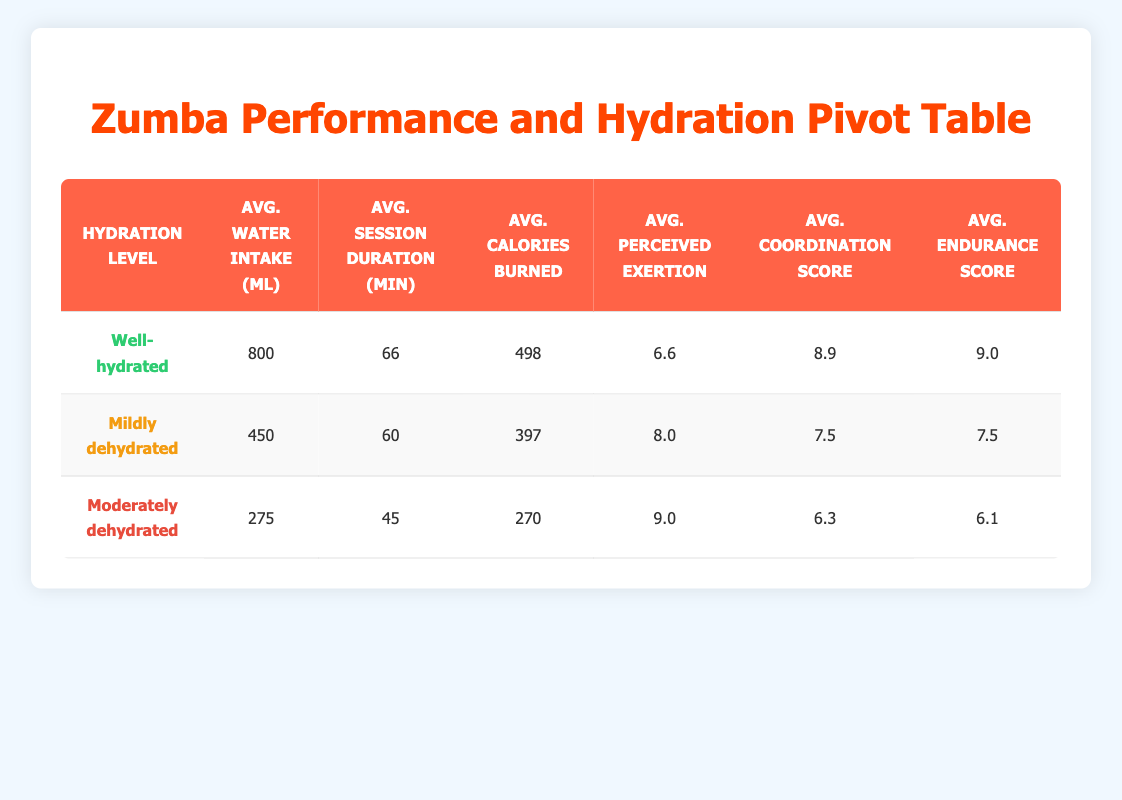What is the average water intake for participants classified as "Well-hydrated"? The table presents an average water intake of 800 ml for participants under the "Well-hydrated" category. This value is directly pulled from the corresponding row in the table.
Answer: 800 ml How many minutes do "Moderately dehydrated" participants spend on average in Zumba sessions? The table shows that "Moderately dehydrated" participants have an average session duration of 45 minutes, which is stated in the respective row.
Answer: 45 min Is the average coordination score higher for "Well-hydrated" participants than for "Mildly dehydrated" participants? Looking at the table, the average coordination score for "Well-hydrated" participants is 8.9, while for "Mildly dehydrated" participants, it is 7.5. Thus, 8.9 is greater than 7.5, making the statement true.
Answer: Yes What is the total average calorie burn for all hydration levels combined? To find this, sum the average calories burned across all hydration levels: 498 (Well-hydrated) + 397 (Mildly dehydrated) + 270 (Moderately dehydrated) = 1165. Then divide by 3 to get an average of 1165/3, which equals approximately 388.33.
Answer: 388.33 How much more does the average calories burned differ between "Well-hydrated" and "Moderately dehydrated" participants? The average calories burned for "Well-hydrated" is 498, and for "Moderately dehydrated," it is 270. The difference is 498 - 270 = 228 calories.
Answer: 228 calories Are participants classified as "Mildly dehydrated" likely to have a higher perceived exertion than those who are "Well-hydrated"? According to the table, the average perceived exertion for "Mildly dehydrated" participants is 8.0, while for "Well-hydrated," it is 6.6. Since 8.0 is greater than 6.6, the answer is yes.
Answer: Yes What is the average endurance score for participants who are "Well-hydrated"? The endurance score for "Well-hydrated" participants is provided as 9.0 in the table, indicating the average endurance level for that group.
Answer: 9.0 If a participant is "Well-hydrated," what is the likelihood they will have a perceived exertion score below 7? The table indicates that the average perceived exertion score for "Well-hydrated" participants is 6.6, which is below 7. Therefore, it is likely that participants in this category will generally score below 7.
Answer: Yes 